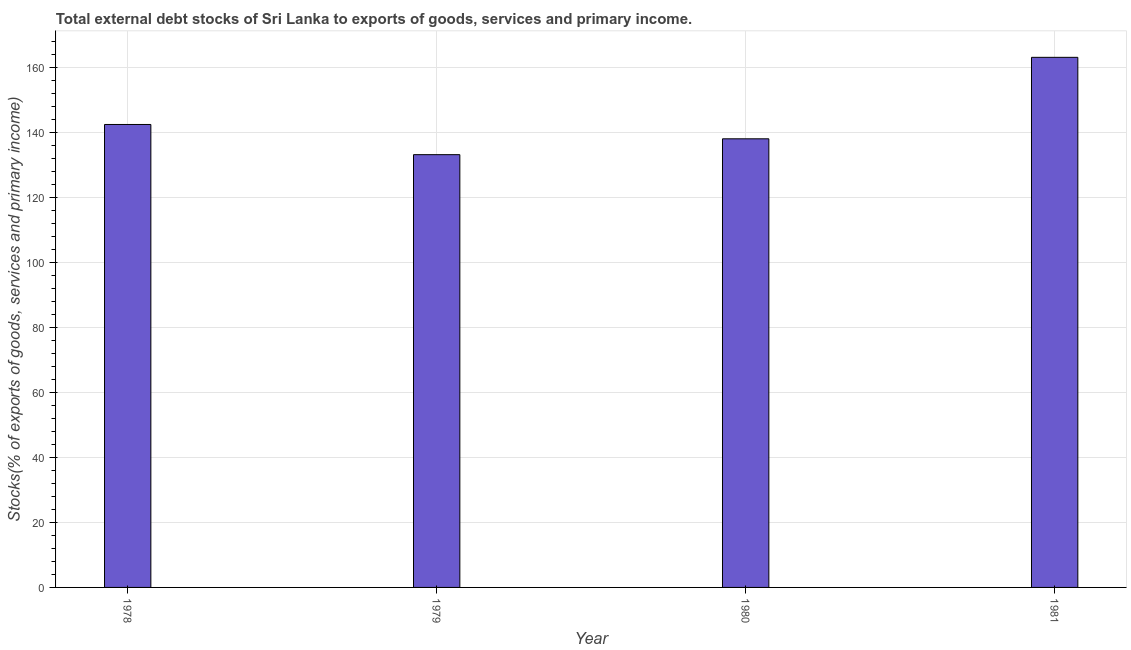What is the title of the graph?
Your answer should be compact. Total external debt stocks of Sri Lanka to exports of goods, services and primary income. What is the label or title of the X-axis?
Provide a succinct answer. Year. What is the label or title of the Y-axis?
Provide a succinct answer. Stocks(% of exports of goods, services and primary income). What is the external debt stocks in 1980?
Ensure brevity in your answer.  137.99. Across all years, what is the maximum external debt stocks?
Your response must be concise. 163.06. Across all years, what is the minimum external debt stocks?
Give a very brief answer. 133.12. In which year was the external debt stocks minimum?
Give a very brief answer. 1979. What is the sum of the external debt stocks?
Your response must be concise. 576.57. What is the difference between the external debt stocks in 1978 and 1980?
Offer a very short reply. 4.41. What is the average external debt stocks per year?
Ensure brevity in your answer.  144.14. What is the median external debt stocks?
Ensure brevity in your answer.  140.2. What is the ratio of the external debt stocks in 1978 to that in 1979?
Ensure brevity in your answer.  1.07. Is the external debt stocks in 1978 less than that in 1981?
Your response must be concise. Yes. What is the difference between the highest and the second highest external debt stocks?
Your response must be concise. 20.65. What is the difference between the highest and the lowest external debt stocks?
Provide a succinct answer. 29.94. In how many years, is the external debt stocks greater than the average external debt stocks taken over all years?
Offer a terse response. 1. How many years are there in the graph?
Offer a terse response. 4. What is the difference between two consecutive major ticks on the Y-axis?
Your answer should be compact. 20. Are the values on the major ticks of Y-axis written in scientific E-notation?
Your response must be concise. No. What is the Stocks(% of exports of goods, services and primary income) in 1978?
Provide a short and direct response. 142.4. What is the Stocks(% of exports of goods, services and primary income) of 1979?
Keep it short and to the point. 133.12. What is the Stocks(% of exports of goods, services and primary income) of 1980?
Your response must be concise. 137.99. What is the Stocks(% of exports of goods, services and primary income) of 1981?
Ensure brevity in your answer.  163.06. What is the difference between the Stocks(% of exports of goods, services and primary income) in 1978 and 1979?
Ensure brevity in your answer.  9.29. What is the difference between the Stocks(% of exports of goods, services and primary income) in 1978 and 1980?
Your answer should be very brief. 4.41. What is the difference between the Stocks(% of exports of goods, services and primary income) in 1978 and 1981?
Provide a short and direct response. -20.65. What is the difference between the Stocks(% of exports of goods, services and primary income) in 1979 and 1980?
Provide a short and direct response. -4.88. What is the difference between the Stocks(% of exports of goods, services and primary income) in 1979 and 1981?
Give a very brief answer. -29.94. What is the difference between the Stocks(% of exports of goods, services and primary income) in 1980 and 1981?
Offer a terse response. -25.06. What is the ratio of the Stocks(% of exports of goods, services and primary income) in 1978 to that in 1979?
Your answer should be very brief. 1.07. What is the ratio of the Stocks(% of exports of goods, services and primary income) in 1978 to that in 1980?
Give a very brief answer. 1.03. What is the ratio of the Stocks(% of exports of goods, services and primary income) in 1978 to that in 1981?
Offer a very short reply. 0.87. What is the ratio of the Stocks(% of exports of goods, services and primary income) in 1979 to that in 1980?
Your answer should be very brief. 0.96. What is the ratio of the Stocks(% of exports of goods, services and primary income) in 1979 to that in 1981?
Keep it short and to the point. 0.82. What is the ratio of the Stocks(% of exports of goods, services and primary income) in 1980 to that in 1981?
Your answer should be very brief. 0.85. 